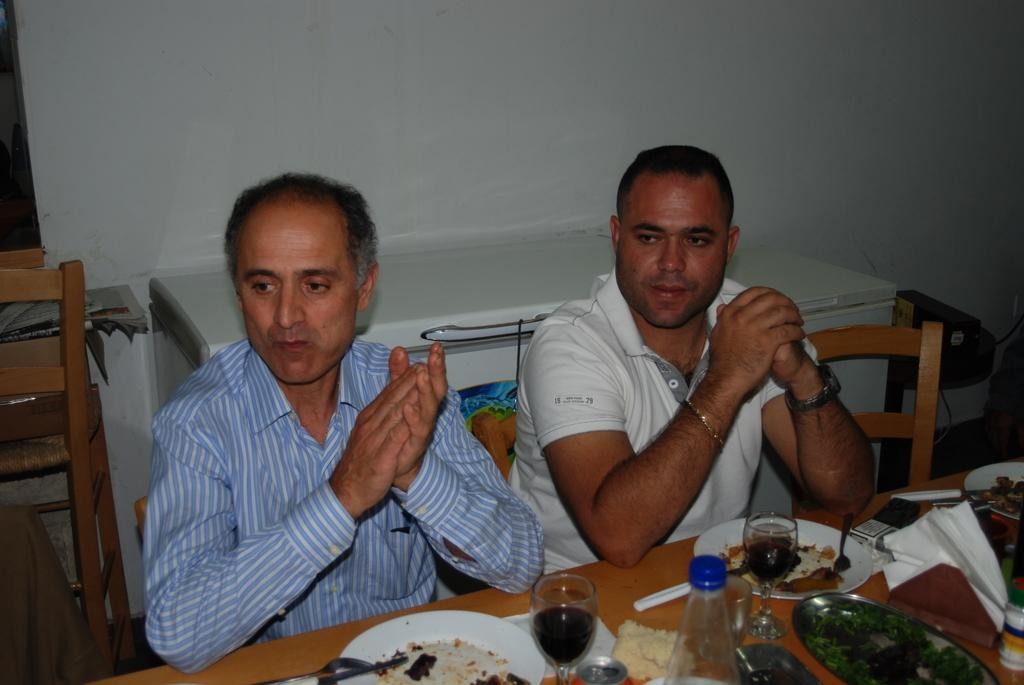How many people are in the image? There are two persons in the image. What are the persons doing in the image? The persons are sitting on chairs. What type of furniture is present in the image? There is a wooden table in the image. What can be found on the wooden table? Food items are present on the wooden table. What type of winter clothing can be seen on the persons in the image? There is no mention of winter clothing or any specific season in the image, so it cannot be determined from the image. 